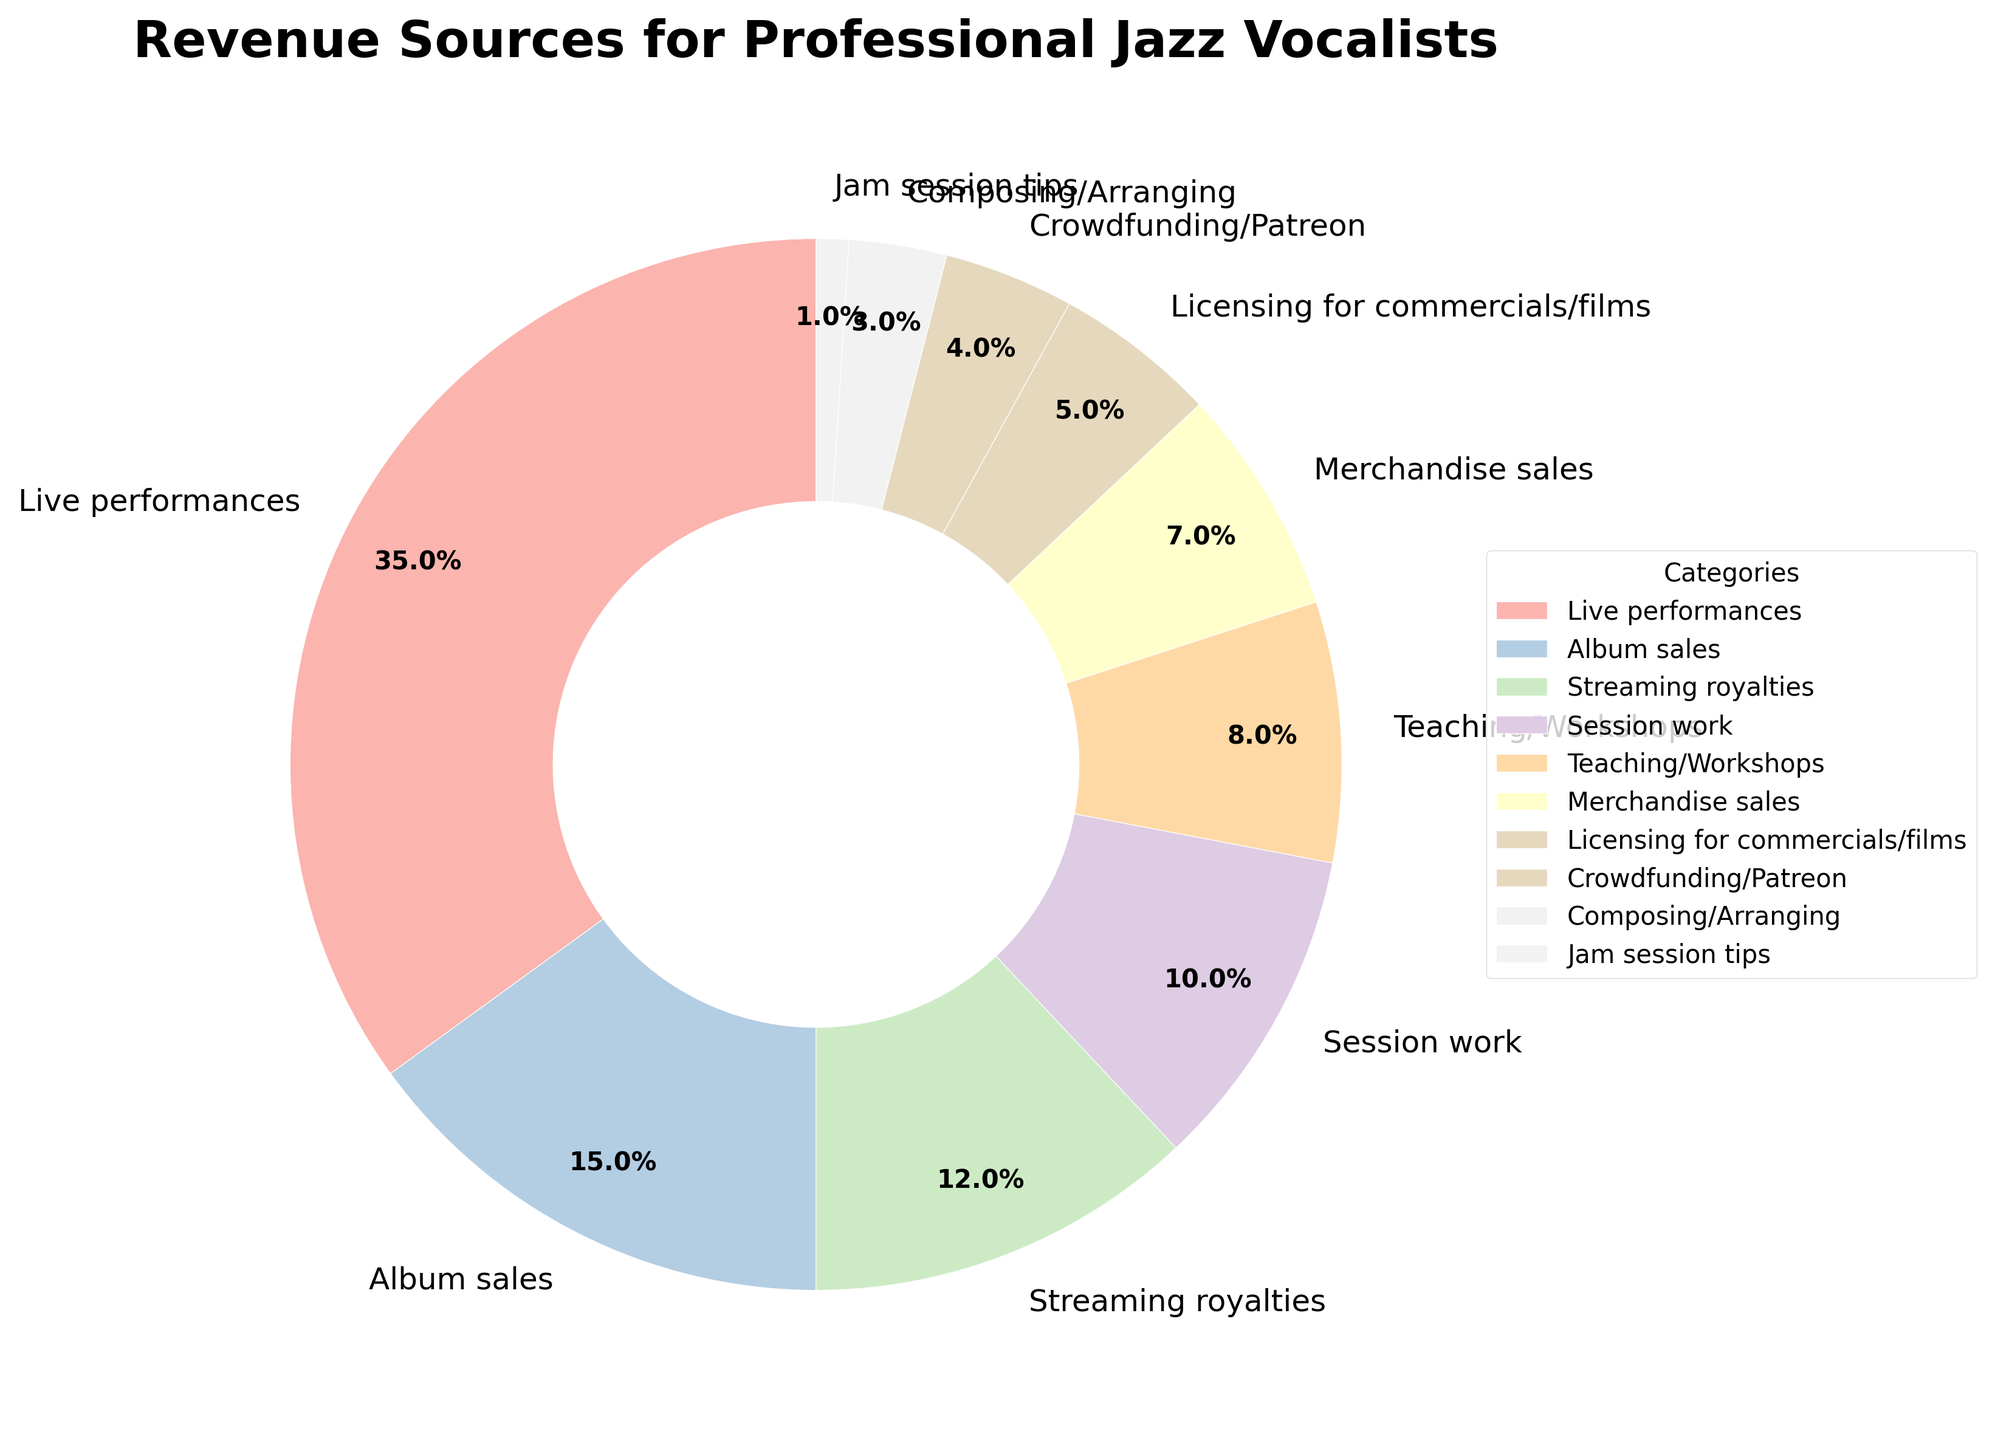What's the largest revenue source for professional jazz vocalists? According to the pie chart, the largest wedge represents the category "Live performances." The percentage for this category is 35%.
Answer: Live performances Which generates more revenue, album sales or streaming royalties? The pie chart shows album sales at 15% and streaming royalties at 12%. Since 15% is greater than 12%, album sales generate more revenue.
Answer: Album sales What is the combined percentage of revenue from teaching/workshops and merchandise sales? Teaching/Workshops account for 8% and Merchandise sales for 7%. Adding these together gives 8% + 7% = 15%.
Answer: 15% Is the revenue from licensing for commercials/films greater than the revenue from composing/arranging? The pie chart shows licensing for commercials/films at 5% and composing/arranging at 3%. Since 5% is greater than 3%, licensing contributes more revenue.
Answer: Yes What percentage of revenue comes from sources other than live performances, album sales, and streaming royalties? First, find the combined percentage of live performances, album sales, and streaming royalties: 35% + 15% + 12% = 62%. Then, subtract this from 100% to find the remaining percentage: 100% - 62% = 38%.
Answer: 38% Which category has a lower revenue percentage, session work or teaching/workshops? The pie chart shows session work at 10% and teaching/workshops at 8%. Since 8% is less than 10%, teaching/workshops have a lower revenue percentage.
Answer: Teaching/Workshops What's the difference in revenue percentage between merchandise sales and crowdfunding/Patreon? The pie chart shows merchandise sales at 7% and crowdfunding/Patreon at 4%. Subtracting these values gives 7% - 4% = 3%.
Answer: 3% What is the smallest revenue source for professional jazz vocalists according to the pie chart? The smallest wedge in the pie chart represents "Jam session tips," which accounts for 1% of the revenue sources.
Answer: Jam session tips How much more revenue do live performances generate compared to session work? Live performances account for 35% while session work accounts for 10%. To find the difference, subtract 10% from 35%: 35% - 10% = 25%.
Answer: 25% List the categories in ascending order of their revenue percentages. Based on the pie chart, the categories in ascending order are: Jam session tips (1%), Composing/Arranging (3%), Crowdfunding/Patreon (4%), Licensing for commercials/films (5%), Merchandise sales (7%), Teaching/Workshops (8%), Session work (10%), Streaming royalties (12%), Album sales (15%), Live performances (35%).
Answer: Jam session tips, Composing/Arranging, Crowdfunding/Patreon, Licensing for commercials/films, Merchandise sales, Teaching/Workshops, Session work, Streaming royalties, Album sales, Live performances 